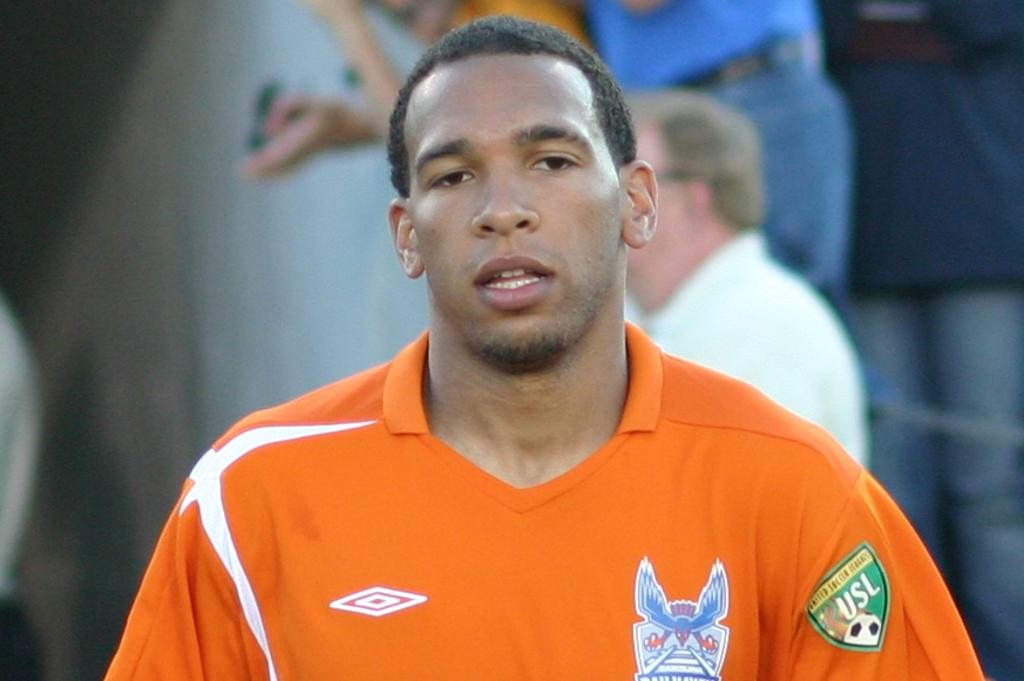Provide a one-sentence caption for the provided image. A man is wearing an orange shirt with a badge for the USL on it. 